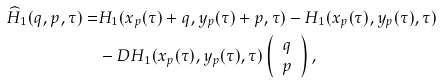<formula> <loc_0><loc_0><loc_500><loc_500>\widehat { H } _ { 1 } ( q , p , \tau ) = & H _ { 1 } ( x _ { p } ( \tau ) + q , y _ { p } ( \tau ) + p , \tau ) - H _ { 1 } ( x _ { p } ( \tau ) , y _ { p } ( \tau ) , \tau ) \\ & - D H _ { 1 } ( x _ { p } ( \tau ) , y _ { p } ( \tau ) , \tau ) \left ( \begin{array} { c } q \\ p \end{array} \right ) ,</formula> 